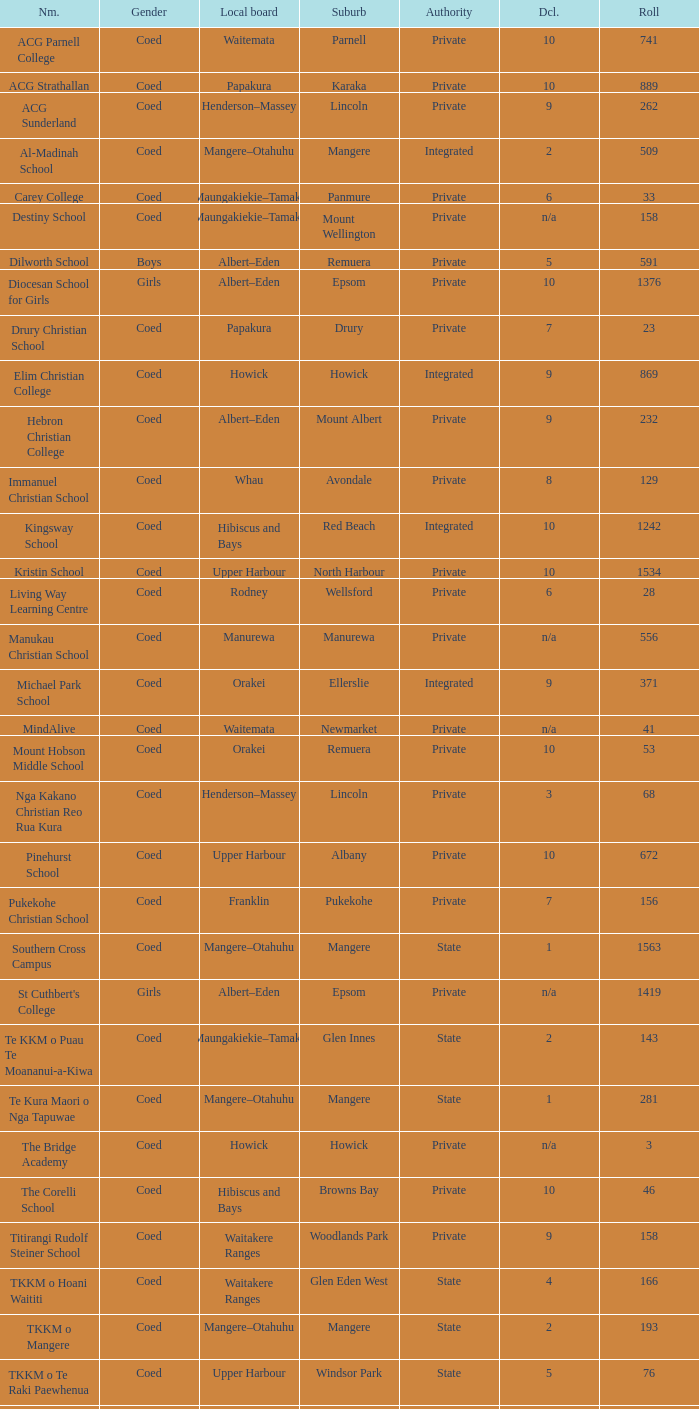What name shows as private authority and hibiscus and bays local board ? The Corelli School. 